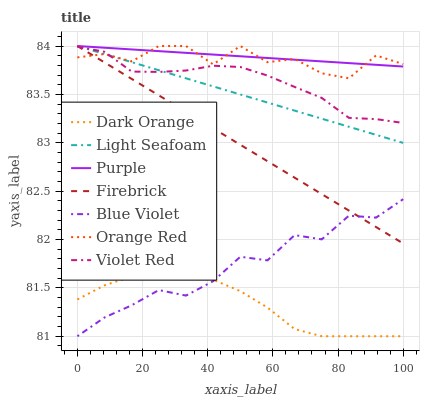Does Dark Orange have the minimum area under the curve?
Answer yes or no. Yes. Does Purple have the maximum area under the curve?
Answer yes or no. Yes. Does Violet Red have the minimum area under the curve?
Answer yes or no. No. Does Violet Red have the maximum area under the curve?
Answer yes or no. No. Is Light Seafoam the smoothest?
Answer yes or no. Yes. Is Orange Red the roughest?
Answer yes or no. Yes. Is Violet Red the smoothest?
Answer yes or no. No. Is Violet Red the roughest?
Answer yes or no. No. Does Violet Red have the lowest value?
Answer yes or no. No. Does Violet Red have the highest value?
Answer yes or no. No. Is Dark Orange less than Firebrick?
Answer yes or no. Yes. Is Purple greater than Dark Orange?
Answer yes or no. Yes. Does Dark Orange intersect Firebrick?
Answer yes or no. No. 